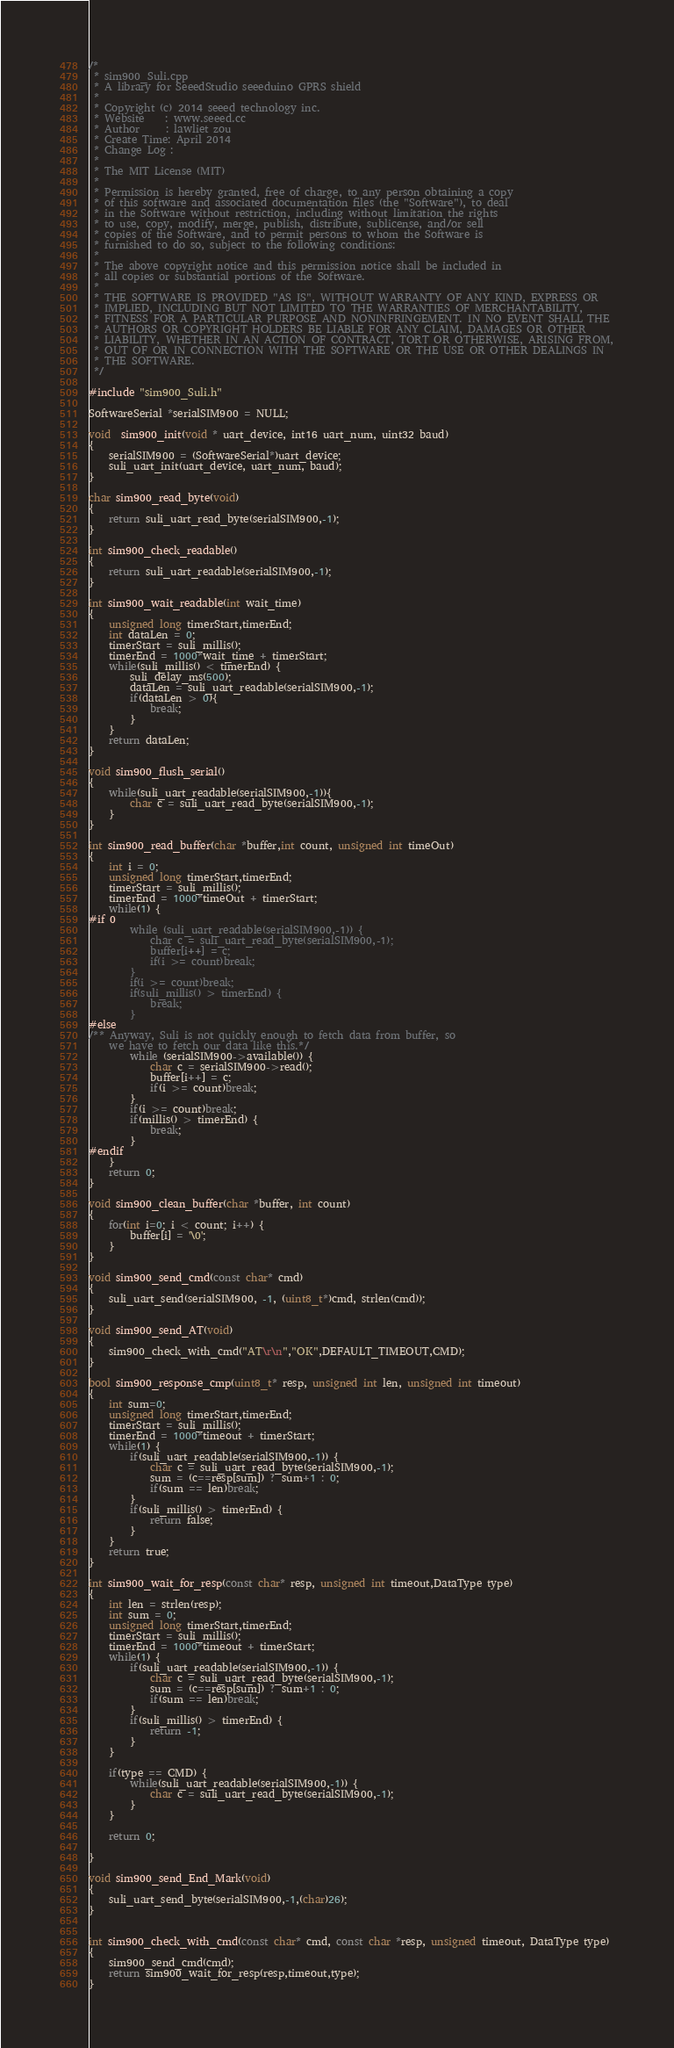Convert code to text. <code><loc_0><loc_0><loc_500><loc_500><_C++_>/*
 * sim900_Suli.cpp
 * A library for SeeedStudio seeeduino GPRS shield 
 *  
 * Copyright (c) 2014 seeed technology inc.
 * Website    : www.seeed.cc
 * Author     : lawliet zou
 * Create Time: April 2014
 * Change Log :
 *
 * The MIT License (MIT)
 *
 * Permission is hereby granted, free of charge, to any person obtaining a copy
 * of this software and associated documentation files (the "Software"), to deal
 * in the Software without restriction, including without limitation the rights
 * to use, copy, modify, merge, publish, distribute, sublicense, and/or sell
 * copies of the Software, and to permit persons to whom the Software is
 * furnished to do so, subject to the following conditions:
 *
 * The above copyright notice and this permission notice shall be included in
 * all copies or substantial portions of the Software.
 *
 * THE SOFTWARE IS PROVIDED "AS IS", WITHOUT WARRANTY OF ANY KIND, EXPRESS OR
 * IMPLIED, INCLUDING BUT NOT LIMITED TO THE WARRANTIES OF MERCHANTABILITY,
 * FITNESS FOR A PARTICULAR PURPOSE AND NONINFRINGEMENT. IN NO EVENT SHALL THE
 * AUTHORS OR COPYRIGHT HOLDERS BE LIABLE FOR ANY CLAIM, DAMAGES OR OTHER
 * LIABILITY, WHETHER IN AN ACTION OF CONTRACT, TORT OR OTHERWISE, ARISING FROM,
 * OUT OF OR IN CONNECTION WITH THE SOFTWARE OR THE USE OR OTHER DEALINGS IN
 * THE SOFTWARE.
 */

#include "sim900_Suli.h"

SoftwareSerial *serialSIM900 = NULL;

void  sim900_init(void * uart_device, int16 uart_num, uint32 baud)
{
    serialSIM900 = (SoftwareSerial*)uart_device;
    suli_uart_init(uart_device, uart_num, baud);
}

char sim900_read_byte(void)
{
    return suli_uart_read_byte(serialSIM900,-1);
}

int sim900_check_readable()
{
    return suli_uart_readable(serialSIM900,-1);
}

int sim900_wait_readable(int wait_time)
{
    unsigned long timerStart,timerEnd;
    int dataLen = 0;
    timerStart = suli_millis();
    timerEnd = 1000*wait_time + timerStart;
    while(suli_millis() < timerEnd) {
        suli_delay_ms(500);
        dataLen = suli_uart_readable(serialSIM900,-1);
        if(dataLen > 0){
            break;
        }
    }
    return dataLen;
}

void sim900_flush_serial()
{
    while(suli_uart_readable(serialSIM900,-1)){
        char c = suli_uart_read_byte(serialSIM900,-1);
    }
}

int sim900_read_buffer(char *buffer,int count, unsigned int timeOut)
{
    int i = 0;
    unsigned long timerStart,timerEnd;
    timerStart = suli_millis();
    timerEnd = 1000*timeOut + timerStart;
    while(1) {
#if 0
        while (suli_uart_readable(serialSIM900,-1)) {
            char c = suli_uart_read_byte(serialSIM900,-1);
            buffer[i++] = c;
            if(i >= count)break;
        }
        if(i >= count)break;
        if(suli_millis() > timerEnd) {
            break;
        }
#else
/** Anyway, Suli is not quickly enough to fetch data from buffer, so 
    we have to fetch our data like this.*/
        while (serialSIM900->available()) {
            char c = serialSIM900->read();
            buffer[i++] = c;
            if(i >= count)break;
        }
        if(i >= count)break;
        if(millis() > timerEnd) {
            break;
        }
#endif
    }
    return 0;   
}

void sim900_clean_buffer(char *buffer, int count)
{
    for(int i=0; i < count; i++) {
        buffer[i] = '\0';
    }
}

void sim900_send_cmd(const char* cmd)
{
    suli_uart_send(serialSIM900, -1, (uint8_t*)cmd, strlen(cmd));
}

void sim900_send_AT(void)
{
    sim900_check_with_cmd("AT\r\n","OK",DEFAULT_TIMEOUT,CMD);
}

bool sim900_response_cmp(uint8_t* resp, unsigned int len, unsigned int timeout)
{
    int sum=0;
    unsigned long timerStart,timerEnd;
    timerStart = suli_millis();
    timerEnd = 1000*timeout + timerStart;
    while(1) {
        if(suli_uart_readable(serialSIM900,-1)) {
            char c = suli_uart_read_byte(serialSIM900,-1);
            sum = (c==resp[sum]) ? sum+1 : 0;
            if(sum == len)break;
        }
        if(suli_millis() > timerEnd) {
            return false;
        }
    }
    return true;    
}

int sim900_wait_for_resp(const char* resp, unsigned int timeout,DataType type)
{
    int len = strlen(resp);
    int sum = 0;
    unsigned long timerStart,timerEnd;
    timerStart = suli_millis();
    timerEnd = 1000*timeout + timerStart;
    while(1) {
        if(suli_uart_readable(serialSIM900,-1)) {
            char c = suli_uart_read_byte(serialSIM900,-1);
            sum = (c==resp[sum]) ? sum+1 : 0;
            if(sum == len)break;
        }
        if(suli_millis() > timerEnd) {
            return -1;
        }
    }

    if(type == CMD) {
        while(suli_uart_readable(serialSIM900,-1)) {
            char c = suli_uart_read_byte(serialSIM900,-1);
        }
    }

    return 0;   

}

void sim900_send_End_Mark(void)
{
    suli_uart_send_byte(serialSIM900,-1,(char)26);
}


int sim900_check_with_cmd(const char* cmd, const char *resp, unsigned timeout, DataType type)
{
    sim900_send_cmd(cmd);
    return sim900_wait_for_resp(resp,timeout,type);
}


</code> 